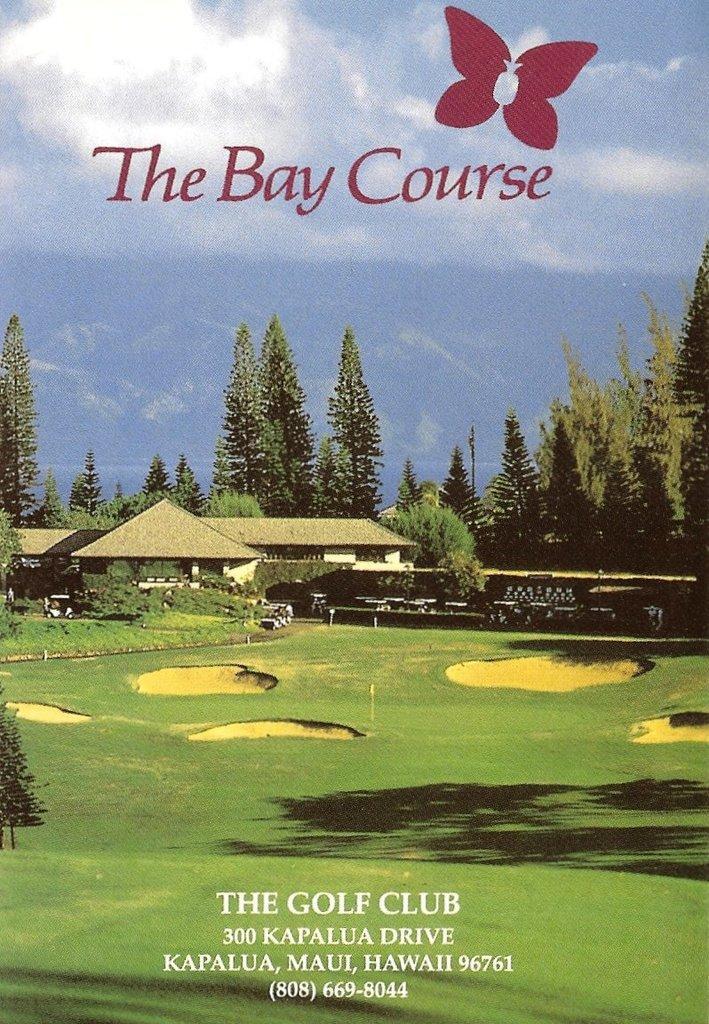<image>
Describe the image concisely. Promo flyer for The Bay Course golf Club in Hawaii. 